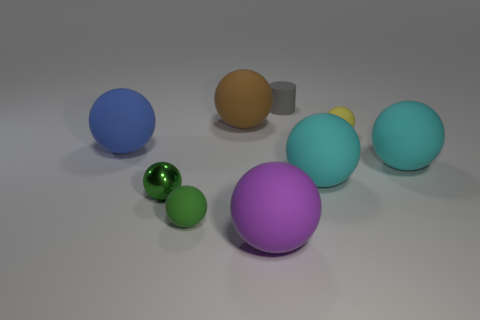Subtract all purple cylinders. How many green balls are left? 2 Subtract all yellow balls. How many balls are left? 7 Subtract all blue balls. How many balls are left? 7 Add 1 metallic spheres. How many objects exist? 10 Subtract all balls. How many objects are left? 1 Add 3 small yellow things. How many small yellow things are left? 4 Add 6 yellow matte things. How many yellow matte things exist? 7 Subtract 0 green blocks. How many objects are left? 9 Subtract all red cylinders. Subtract all red blocks. How many cylinders are left? 1 Subtract all tiny blue rubber balls. Subtract all large blue rubber objects. How many objects are left? 8 